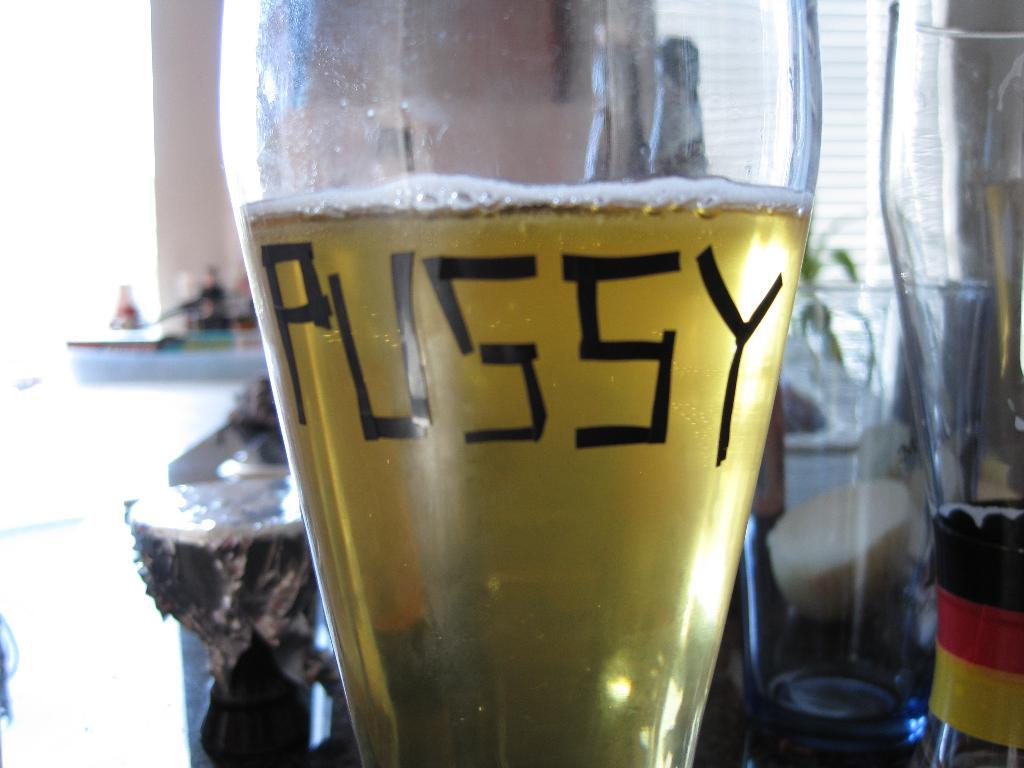<image>
Share a concise interpretation of the image provided. A glass of liquid with the word pussy on in in black. 